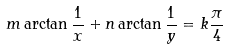Convert formula to latex. <formula><loc_0><loc_0><loc_500><loc_500>m \arctan { \frac { 1 } { x } } + n \arctan { \frac { 1 } { y } } = k { \frac { \pi } { 4 } }</formula> 